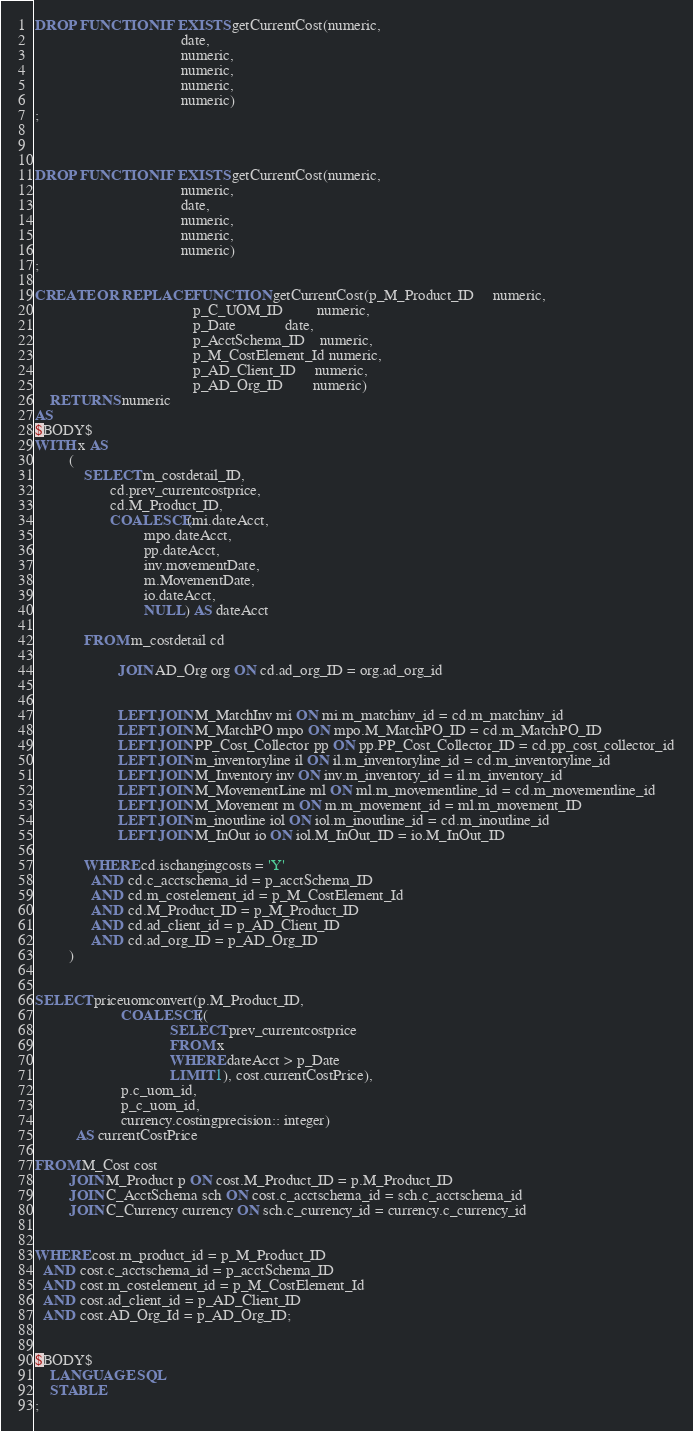<code> <loc_0><loc_0><loc_500><loc_500><_SQL_>DROP FUNCTION IF EXISTS getCurrentCost(numeric,
                                       date,
                                       numeric,
                                       numeric,
                                       numeric,
                                       numeric)
;



DROP FUNCTION IF EXISTS getCurrentCost(numeric,
                                       numeric,
                                       date,
                                       numeric,
                                       numeric,
                                       numeric)
;

CREATE OR REPLACE FUNCTION getCurrentCost(p_M_Product_ID     numeric,
                                          p_C_UOM_ID         numeric,
                                          p_Date             date,
                                          p_AcctSchema_ID    numeric,
                                          p_M_CostElement_Id numeric,
                                          p_AD_Client_ID     numeric,
                                          p_AD_Org_ID        numeric)
    RETURNS numeric
AS
$BODY$
WITH x AS
         (
             SELECT m_costdetail_ID,
                    cd.prev_currentcostprice,
                    cd.M_Product_ID,
                    COALESCE(mi.dateAcct,
                             mpo.dateAcct,
                             pp.dateAcct,
                             inv.movementDate,
                             m.MovementDate,
                             io.dateAcct,
                             NULL) AS dateAcct

             FROM m_costdetail cd

                      JOIN AD_Org org ON cd.ad_org_ID = org.ad_org_id


                      LEFT JOIN M_MatchInv mi ON mi.m_matchinv_id = cd.m_matchinv_id
                      LEFT JOIN M_MatchPO mpo ON mpo.M_MatchPO_ID = cd.m_MatchPO_ID
                      LEFT JOIN PP_Cost_Collector pp ON pp.PP_Cost_Collector_ID = cd.pp_cost_collector_id
                      LEFT JOIN m_inventoryline il ON il.m_inventoryline_id = cd.m_inventoryline_id
                      LEFT JOIN M_Inventory inv ON inv.m_inventory_id = il.m_inventory_id
                      LEFT JOIN M_MovementLine ml ON ml.m_movementline_id = cd.m_movementline_id
                      LEFT JOIN M_Movement m ON m.m_movement_id = ml.m_movement_ID
                      LEFT JOIN m_inoutline iol ON iol.m_inoutline_id = cd.m_inoutline_id
                      LEFT JOIN M_InOut io ON iol.M_InOut_ID = io.M_InOut_ID

             WHERE cd.ischangingcosts = 'Y'
               AND cd.c_acctschema_id = p_acctSchema_ID
               AND cd.m_costelement_id = p_M_CostElement_Id
               AND cd.M_Product_ID = p_M_Product_ID
               AND cd.ad_client_id = p_AD_Client_ID
               AND cd.ad_org_ID = p_AD_Org_ID
         )


SELECT priceuomconvert(p.M_Product_ID,
                       COALESCE((
                                    SELECT prev_currentcostprice
                                    FROM x
                                    WHERE dateAcct > p_Date
                                    LIMIT 1), cost.currentCostPrice),
                       p.c_uom_id,
                       p_c_uom_id,
                       currency.costingprecision:: integer)
           AS currentCostPrice

FROM M_Cost cost
         JOIN M_Product p ON cost.M_Product_ID = p.M_Product_ID
         JOIN C_AcctSchema sch ON cost.c_acctschema_id = sch.c_acctschema_id
         JOIN C_Currency currency ON sch.c_currency_id = currency.c_currency_id


WHERE cost.m_product_id = p_M_Product_ID
  AND cost.c_acctschema_id = p_acctSchema_ID
  AND cost.m_costelement_id = p_M_CostElement_Id
  AND cost.ad_client_id = p_AD_Client_ID
  AND cost.AD_Org_Id = p_AD_Org_ID;


$BODY$
    LANGUAGE SQL
    STABLE
;
</code> 